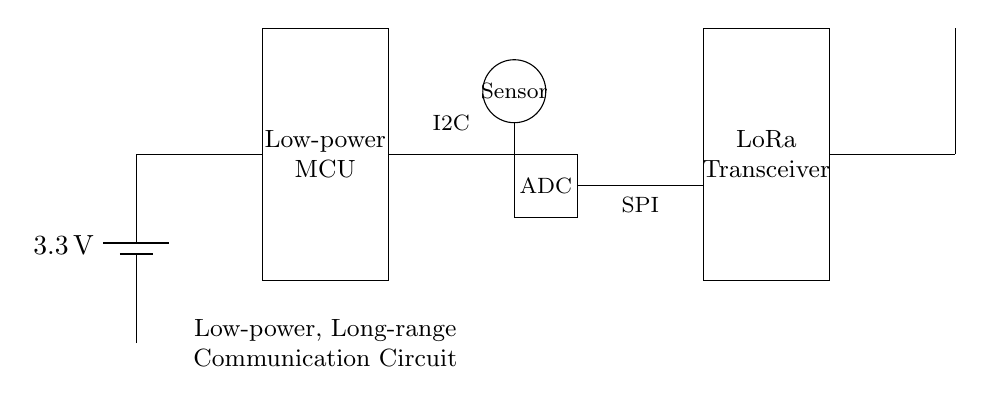What is the voltage of the power supply? The circuit diagram shows a battery marked with a potential difference of three point three volts next to it. This indicates that the voltage of the power supply is three point three volts.
Answer: three point three volts What type of microcontroller is used? The microcontroller is labeled as a low-power MCU in the diagram. Thus, it identifies the type of microcontroller utilized is specifically a low-power MCU aimed at energy efficiency.
Answer: low-power MCU What communication method does the circuit use to transmit data? The diagram includes a LoRa transceiver, which is known for long-range communication capabilities. This indicates that the circuit uses LoRa for data transmission.
Answer: LoRa How is the sensor connected to the rest of the circuit? The circuit shows a line connecting the sensor to the ADC (Analog-to-Digital Converter), which implies that the sensor's output is fed into the ADC for processing before sending to the microcontroller.
Answer: Connected to ADC What is the relationship between the ADC and the LoRa transceiver? The diagram depicts a connection line leading from the ADC to the LoRa transceiver, indicating that the ADC processes the sensor data and sends it to the LoRa transceiver for wireless transmission.
Answer: ADC sends data to LoRa transceiver What is the purpose of the antenna in this circuit? The antenna is shown connected to the LoRa transceiver and its primary purpose is to transmit the data wirelessly over long distances, making it essential for remote patient monitoring.
Answer: To transmit data wirelessly 